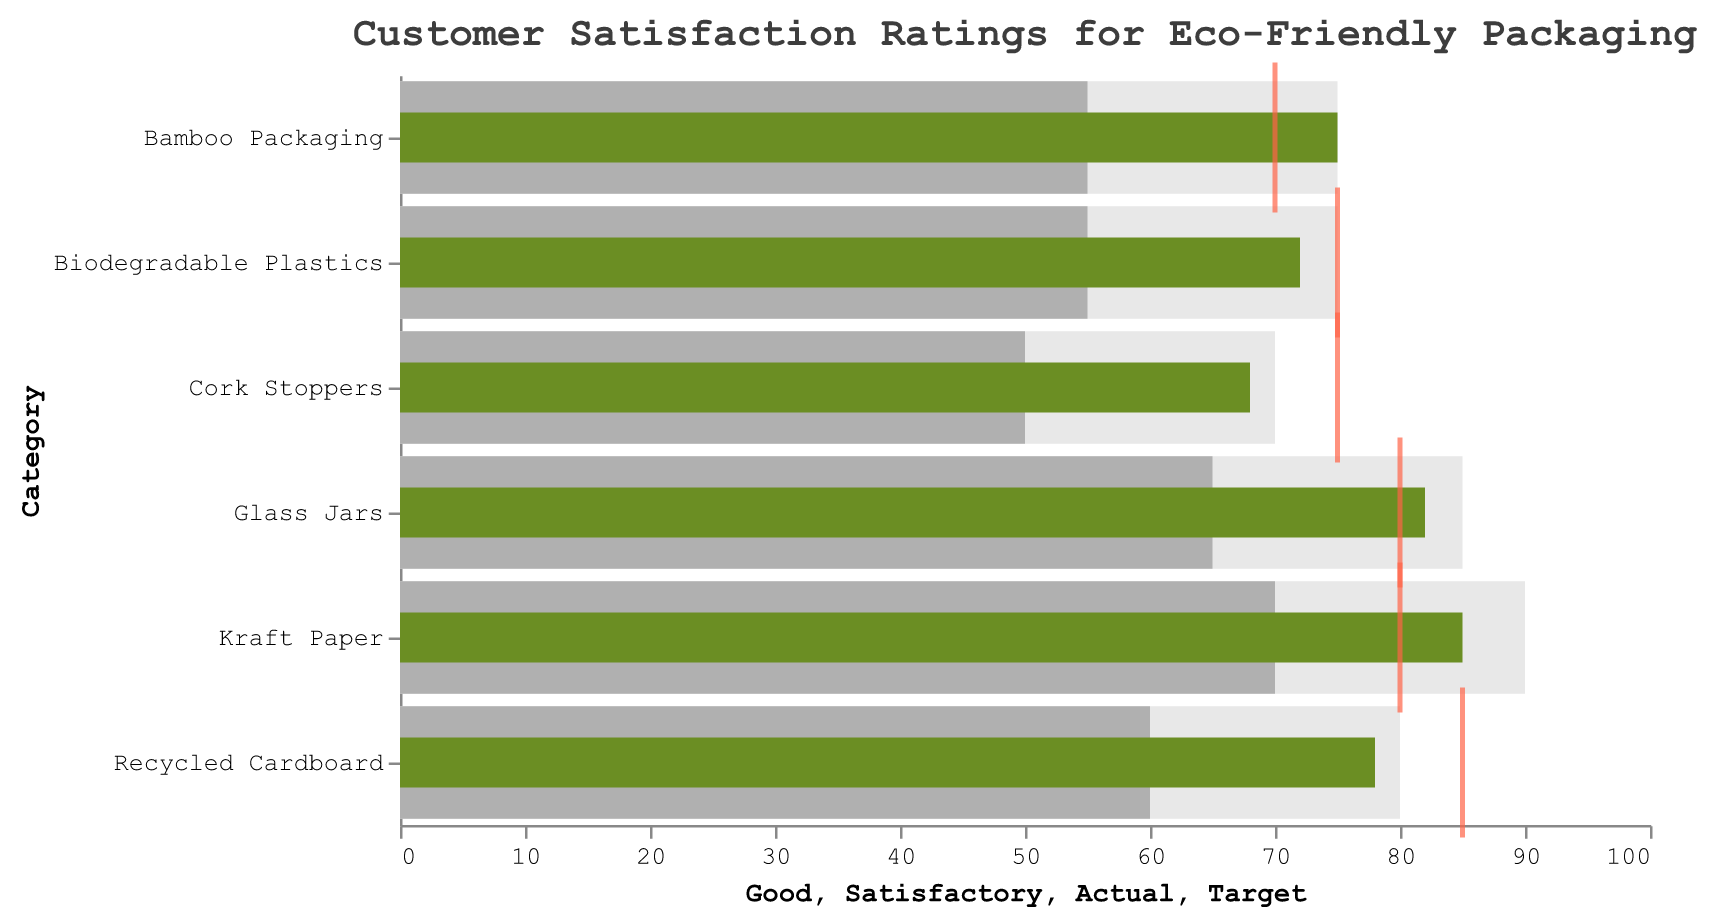What is the title of the figure? The title of the figure is displayed at the top of the chart and provides a description of the data being visualized.
Answer: Customer Satisfaction Ratings for Eco-Friendly Packaging What is the highest customer satisfaction rating achieved among all categories? Identify the highest 'Actual' value among all categories on the chart. The highest bar represents this value.
Answer: 85 Which category has the lowest customer satisfaction rating? Locate the category with the smallest 'Actual' value. This is the shortest green bar on the chart.
Answer: Cork Stoppers What target rating was set for Kraft Paper? Find the tick mark positioned on the bar of the category "Kraft Paper." The x-axis value corresponding to this tick mark represents the target.
Answer: 80 How many categories achieved their target ratings? Compare the 'Actual' value and the 'Target' value for each category to determine how many categories had 'Actual' greater than or equal to 'Target.' Count how many such instances exist.
Answer: 4 Which category exceeded its target rating by the largest margin? Compute the difference between 'Actual' and 'Target' for each category. Identify the category with the largest positive difference.
Answer: Bamboo Packaging How does the customer satisfaction rating for Glass Jars compare to its target rating? Compare the 'Actual' value of "Glass Jars" with its 'Target' value. Check if 'Actual' is greater than, less than, or equal to the 'Target.'
Answer: Greater than What is the mean target rating across all categories? Sum the 'Target' ratings for all categories and divide by the total number of categories. The formula is (85 + 80 + 70 + 75 + 75 + 80) / 6.
Answer: 77.5 Which category is rated 'Good' but did not meet its target rating? Identify categories with an 'Actual' value within the 'Good' range but less than their 'Target.' Inspect each bar and its corresponding tick mark.
Answer: Recycled Cardboard What is the average customer satisfaction rating for eco-friendly packaging materials? Sum all 'Actual' ratings and divide by the number of categories. The formula is (78 + 82 + 75 + 68 + 72 + 85) / 6.
Answer: 76 